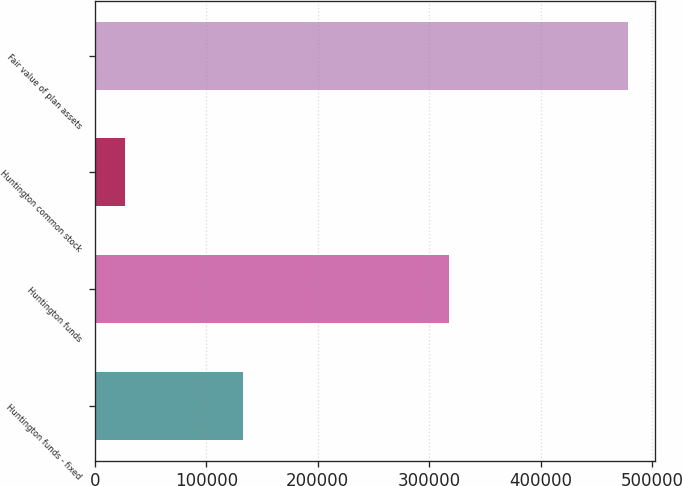Convert chart to OTSL. <chart><loc_0><loc_0><loc_500><loc_500><bar_chart><fcel>Huntington funds - fixed<fcel>Huntington funds<fcel>Huntington common stock<fcel>Fair value of plan assets<nl><fcel>133330<fcel>318155<fcel>26969<fcel>478479<nl></chart> 